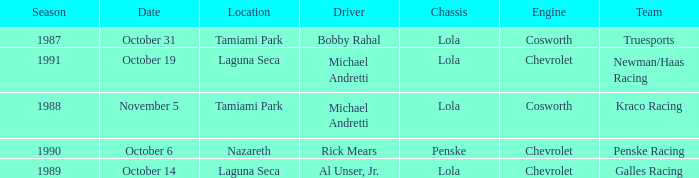At which location did Rick Mears drive? Nazareth. 